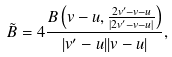Convert formula to latex. <formula><loc_0><loc_0><loc_500><loc_500>\tilde { B } = 4 \frac { B \left ( v - u , { \frac { 2 v ^ { \prime } - v - u } { | 2 v ^ { \prime } - v - u | } } \right ) } { | v ^ { \prime } - u | | v - u | } ,</formula> 